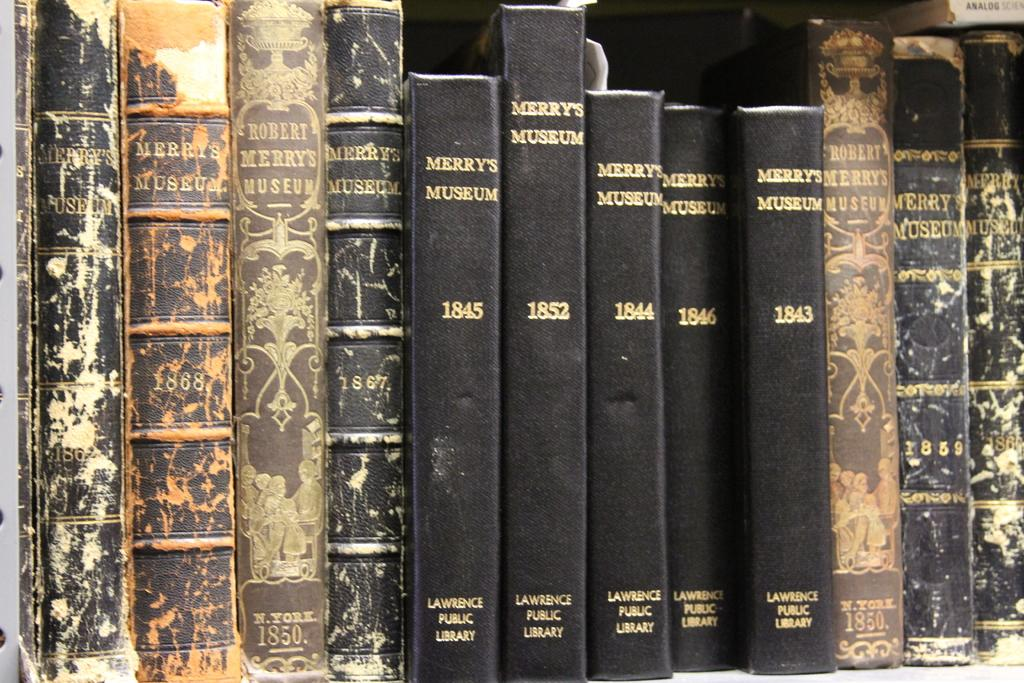<image>
Relay a brief, clear account of the picture shown. Volumes of Merry's museum from 1843 to 1852 sit together on a shelf. 